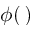Convert formula to latex. <formula><loc_0><loc_0><loc_500><loc_500>\phi ( \, )</formula> 